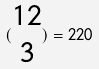Convert formula to latex. <formula><loc_0><loc_0><loc_500><loc_500>( \begin{matrix} 1 2 \\ 3 \end{matrix} ) = 2 2 0</formula> 